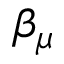<formula> <loc_0><loc_0><loc_500><loc_500>\beta _ { \mu }</formula> 